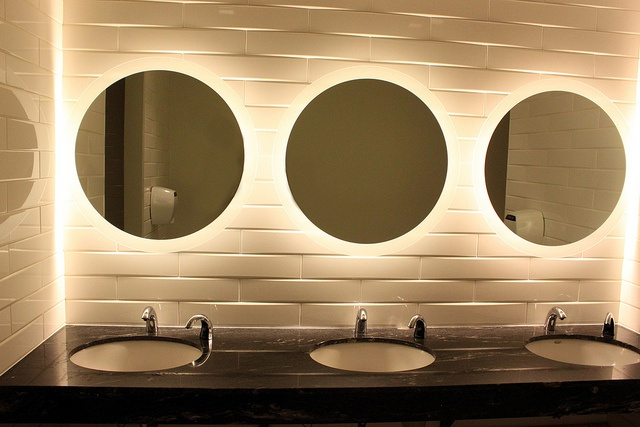Describe the objects in this image and their specific colors. I can see sink in tan, gray, and black tones, sink in tan and gray tones, and sink in tan, gray, black, and brown tones in this image. 